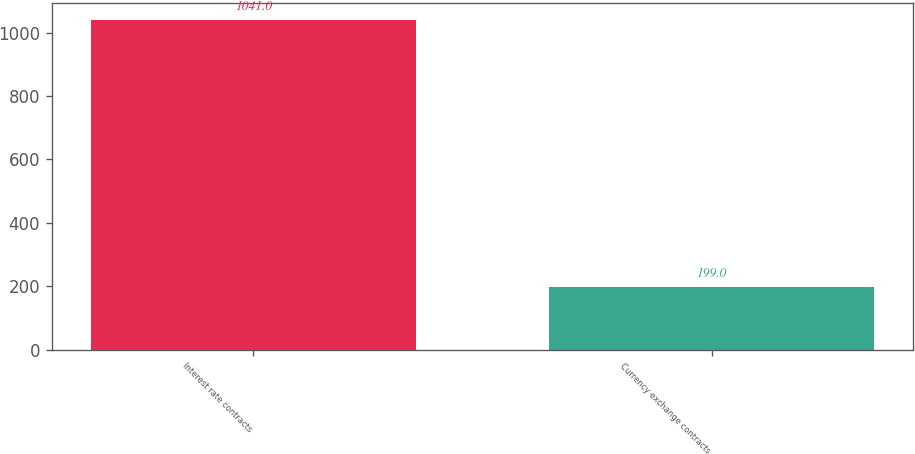Convert chart. <chart><loc_0><loc_0><loc_500><loc_500><bar_chart><fcel>Interest rate contracts<fcel>Currency exchange contracts<nl><fcel>1041<fcel>199<nl></chart> 